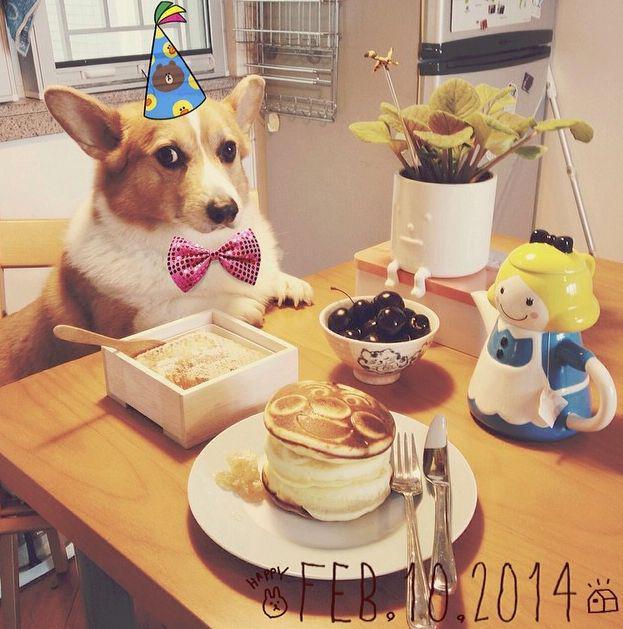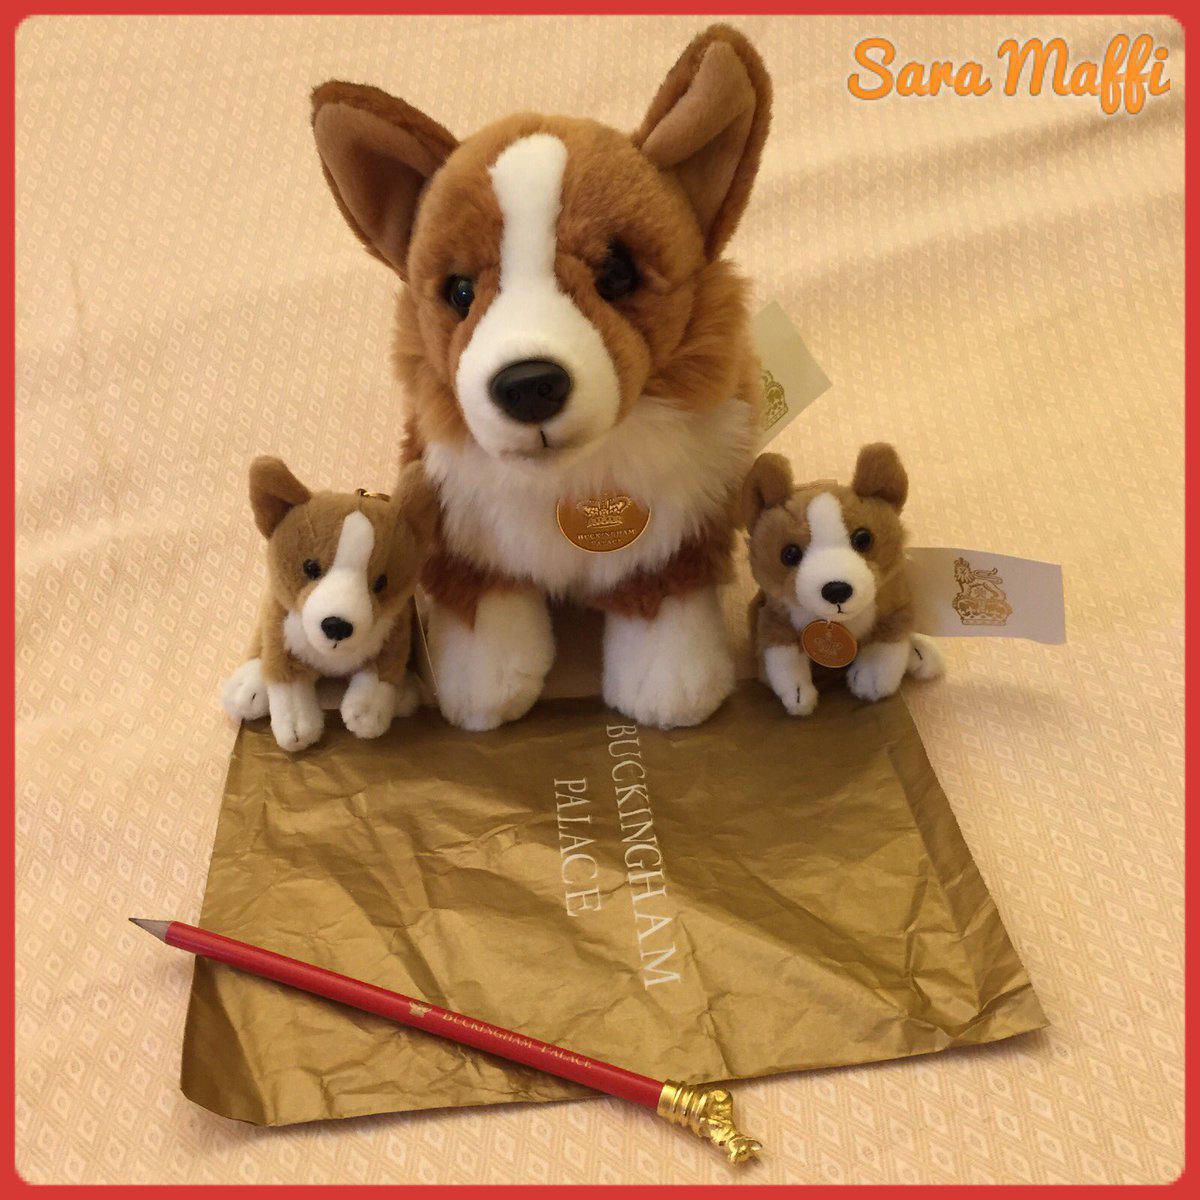The first image is the image on the left, the second image is the image on the right. Given the left and right images, does the statement "Both images feature the same number of dogs." hold true? Answer yes or no. No. The first image is the image on the left, the second image is the image on the right. Given the left and right images, does the statement "A corgi wearing a tie around his neck is behind a table with his front paws propped on its edge." hold true? Answer yes or no. Yes. 